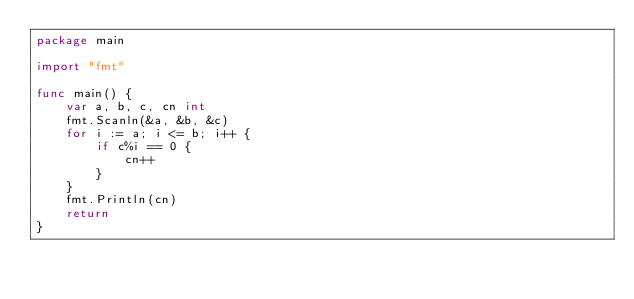Convert code to text. <code><loc_0><loc_0><loc_500><loc_500><_Go_>package main

import "fmt"

func main() {
	var a, b, c, cn int
	fmt.Scanln(&a, &b, &c)
	for i := a; i <= b; i++ {
		if c%i == 0 {
			cn++
		}
	}
	fmt.Println(cn)
	return
}

</code> 